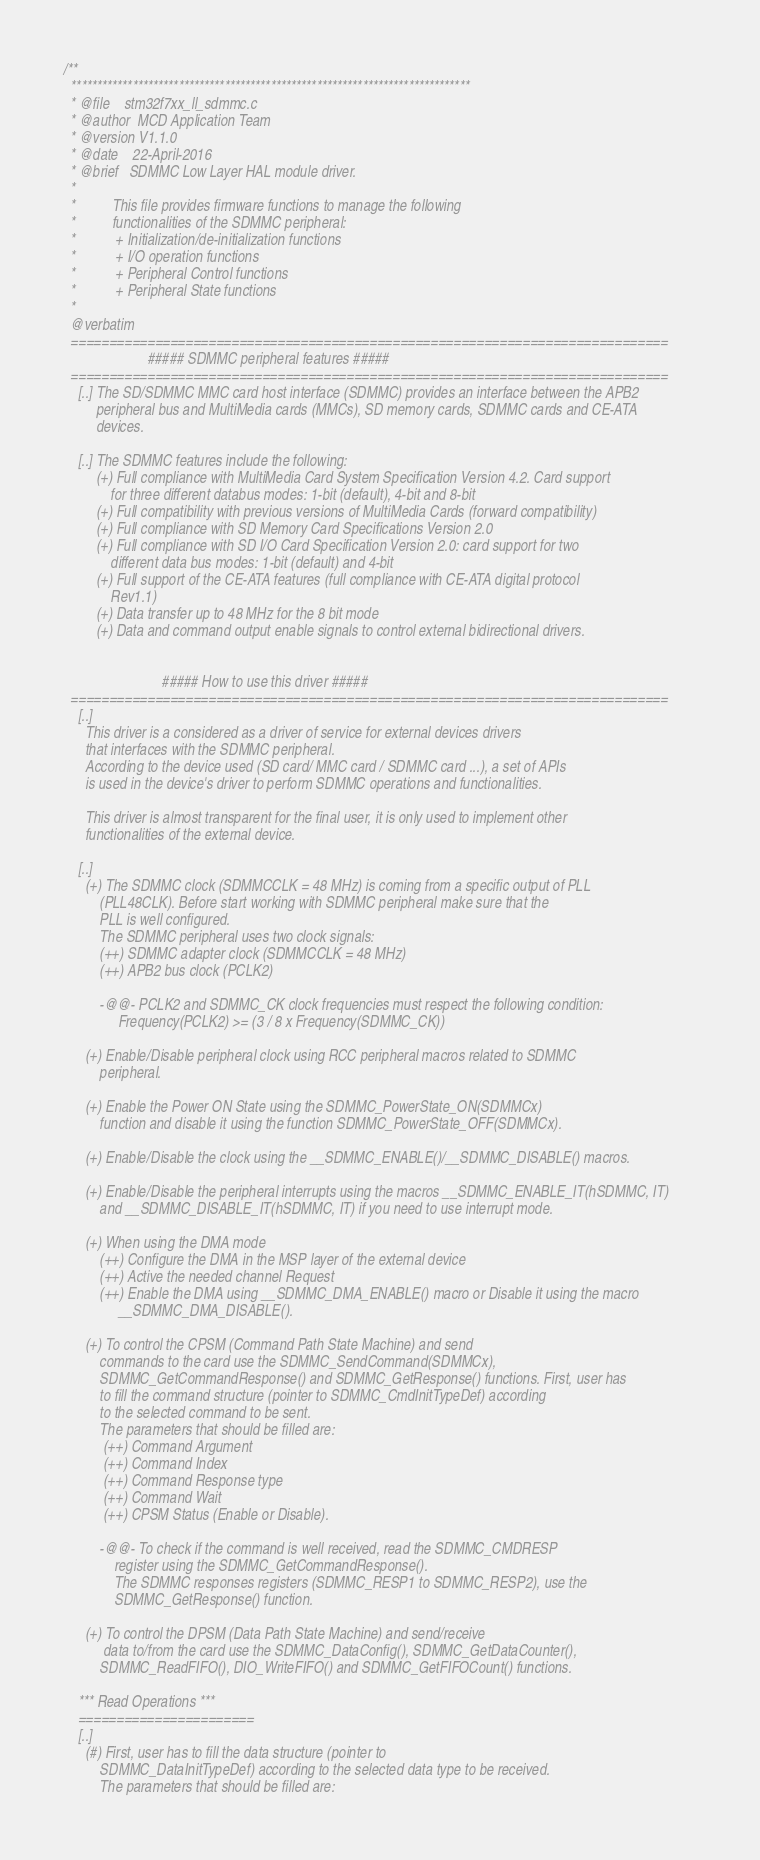<code> <loc_0><loc_0><loc_500><loc_500><_C_>/**
  ******************************************************************************
  * @file    stm32f7xx_ll_sdmmc.c
  * @author  MCD Application Team
  * @version V1.1.0
  * @date    22-April-2016
  * @brief   SDMMC Low Layer HAL module driver.
  *    
  *          This file provides firmware functions to manage the following 
  *          functionalities of the SDMMC peripheral:
  *           + Initialization/de-initialization functions
  *           + I/O operation functions
  *           + Peripheral Control functions 
  *           + Peripheral State functions
  *         
  @verbatim
  ==============================================================================
                       ##### SDMMC peripheral features #####
  ==============================================================================        
    [..] The SD/SDMMC MMC card host interface (SDMMC) provides an interface between the APB2
         peripheral bus and MultiMedia cards (MMCs), SD memory cards, SDMMC cards and CE-ATA
         devices.
    
    [..] The SDMMC features include the following:
         (+) Full compliance with MultiMedia Card System Specification Version 4.2. Card support
             for three different databus modes: 1-bit (default), 4-bit and 8-bit
         (+) Full compatibility with previous versions of MultiMedia Cards (forward compatibility)
         (+) Full compliance with SD Memory Card Specifications Version 2.0
         (+) Full compliance with SD I/O Card Specification Version 2.0: card support for two
             different data bus modes: 1-bit (default) and 4-bit
         (+) Full support of the CE-ATA features (full compliance with CE-ATA digital protocol
             Rev1.1)
         (+) Data transfer up to 48 MHz for the 8 bit mode
         (+) Data and command output enable signals to control external bidirectional drivers.
                 
   
                           ##### How to use this driver #####
  ==============================================================================
    [..]
      This driver is a considered as a driver of service for external devices drivers 
      that interfaces with the SDMMC peripheral.
      According to the device used (SD card/ MMC card / SDMMC card ...), a set of APIs 
      is used in the device's driver to perform SDMMC operations and functionalities.
   
      This driver is almost transparent for the final user, it is only used to implement other
      functionalities of the external device.
   
    [..]
      (+) The SDMMC clock (SDMMCCLK = 48 MHz) is coming from a specific output of PLL 
          (PLL48CLK). Before start working with SDMMC peripheral make sure that the
          PLL is well configured.
          The SDMMC peripheral uses two clock signals:
          (++) SDMMC adapter clock (SDMMCCLK = 48 MHz)
          (++) APB2 bus clock (PCLK2)
       
          -@@- PCLK2 and SDMMC_CK clock frequencies must respect the following condition:
               Frequency(PCLK2) >= (3 / 8 x Frequency(SDMMC_CK))
  
      (+) Enable/Disable peripheral clock using RCC peripheral macros related to SDMMC
          peripheral.

      (+) Enable the Power ON State using the SDMMC_PowerState_ON(SDMMCx) 
          function and disable it using the function SDMMC_PowerState_OFF(SDMMCx).
                
      (+) Enable/Disable the clock using the __SDMMC_ENABLE()/__SDMMC_DISABLE() macros.
  
      (+) Enable/Disable the peripheral interrupts using the macros __SDMMC_ENABLE_IT(hSDMMC, IT) 
          and __SDMMC_DISABLE_IT(hSDMMC, IT) if you need to use interrupt mode. 
  
      (+) When using the DMA mode 
          (++) Configure the DMA in the MSP layer of the external device
          (++) Active the needed channel Request 
          (++) Enable the DMA using __SDMMC_DMA_ENABLE() macro or Disable it using the macro
               __SDMMC_DMA_DISABLE().
  
      (+) To control the CPSM (Command Path State Machine) and send 
          commands to the card use the SDMMC_SendCommand(SDMMCx), 
          SDMMC_GetCommandResponse() and SDMMC_GetResponse() functions. First, user has
          to fill the command structure (pointer to SDMMC_CmdInitTypeDef) according 
          to the selected command to be sent.
          The parameters that should be filled are:
           (++) Command Argument
           (++) Command Index
           (++) Command Response type
           (++) Command Wait
           (++) CPSM Status (Enable or Disable).
  
          -@@- To check if the command is well received, read the SDMMC_CMDRESP
              register using the SDMMC_GetCommandResponse().
              The SDMMC responses registers (SDMMC_RESP1 to SDMMC_RESP2), use the
              SDMMC_GetResponse() function.
  
      (+) To control the DPSM (Data Path State Machine) and send/receive 
           data to/from the card use the SDMMC_DataConfig(), SDMMC_GetDataCounter(), 
          SDMMC_ReadFIFO(), DIO_WriteFIFO() and SDMMC_GetFIFOCount() functions.
  
    *** Read Operations ***
    =======================
    [..]
      (#) First, user has to fill the data structure (pointer to
          SDMMC_DataInitTypeDef) according to the selected data type to be received.
          The parameters that should be filled are:</code> 